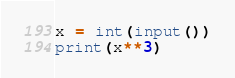Convert code to text. <code><loc_0><loc_0><loc_500><loc_500><_Python_>x = int(input())
print(x**3)
</code> 